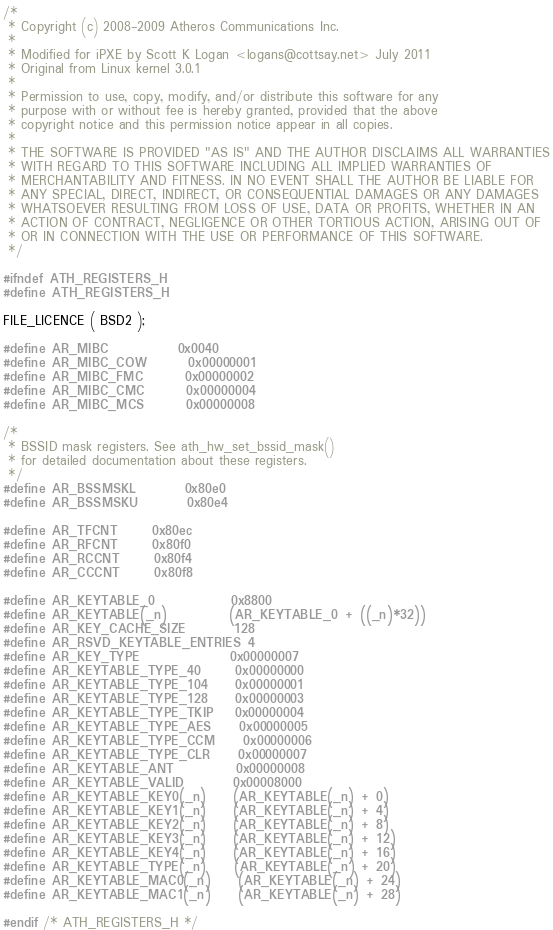Convert code to text. <code><loc_0><loc_0><loc_500><loc_500><_C_>/*
 * Copyright (c) 2008-2009 Atheros Communications Inc.
 *
 * Modified for iPXE by Scott K Logan <logans@cottsay.net> July 2011
 * Original from Linux kernel 3.0.1
 *
 * Permission to use, copy, modify, and/or distribute this software for any
 * purpose with or without fee is hereby granted, provided that the above
 * copyright notice and this permission notice appear in all copies.
 *
 * THE SOFTWARE IS PROVIDED "AS IS" AND THE AUTHOR DISCLAIMS ALL WARRANTIES
 * WITH REGARD TO THIS SOFTWARE INCLUDING ALL IMPLIED WARRANTIES OF
 * MERCHANTABILITY AND FITNESS. IN NO EVENT SHALL THE AUTHOR BE LIABLE FOR
 * ANY SPECIAL, DIRECT, INDIRECT, OR CONSEQUENTIAL DAMAGES OR ANY DAMAGES
 * WHATSOEVER RESULTING FROM LOSS OF USE, DATA OR PROFITS, WHETHER IN AN
 * ACTION OF CONTRACT, NEGLIGENCE OR OTHER TORTIOUS ACTION, ARISING OUT OF
 * OR IN CONNECTION WITH THE USE OR PERFORMANCE OF THIS SOFTWARE.
 */

#ifndef ATH_REGISTERS_H
#define ATH_REGISTERS_H

FILE_LICENCE ( BSD2 );

#define AR_MIBC			0x0040
#define AR_MIBC_COW		0x00000001
#define AR_MIBC_FMC		0x00000002
#define AR_MIBC_CMC		0x00000004
#define AR_MIBC_MCS		0x00000008

/*
 * BSSID mask registers. See ath_hw_set_bssid_mask()
 * for detailed documentation about these registers.
 */
#define AR_BSSMSKL		0x80e0
#define AR_BSSMSKU		0x80e4

#define AR_TFCNT		0x80ec
#define AR_RFCNT		0x80f0
#define AR_RCCNT		0x80f4
#define AR_CCCNT		0x80f8

#define AR_KEYTABLE_0           0x8800
#define AR_KEYTABLE(_n)         (AR_KEYTABLE_0 + ((_n)*32))
#define AR_KEY_CACHE_SIZE       128
#define AR_RSVD_KEYTABLE_ENTRIES 4
#define AR_KEY_TYPE             0x00000007
#define AR_KEYTABLE_TYPE_40     0x00000000
#define AR_KEYTABLE_TYPE_104    0x00000001
#define AR_KEYTABLE_TYPE_128    0x00000003
#define AR_KEYTABLE_TYPE_TKIP   0x00000004
#define AR_KEYTABLE_TYPE_AES    0x00000005
#define AR_KEYTABLE_TYPE_CCM    0x00000006
#define AR_KEYTABLE_TYPE_CLR    0x00000007
#define AR_KEYTABLE_ANT         0x00000008
#define AR_KEYTABLE_VALID       0x00008000
#define AR_KEYTABLE_KEY0(_n)    (AR_KEYTABLE(_n) + 0)
#define AR_KEYTABLE_KEY1(_n)    (AR_KEYTABLE(_n) + 4)
#define AR_KEYTABLE_KEY2(_n)    (AR_KEYTABLE(_n) + 8)
#define AR_KEYTABLE_KEY3(_n)    (AR_KEYTABLE(_n) + 12)
#define AR_KEYTABLE_KEY4(_n)    (AR_KEYTABLE(_n) + 16)
#define AR_KEYTABLE_TYPE(_n)    (AR_KEYTABLE(_n) + 20)
#define AR_KEYTABLE_MAC0(_n)    (AR_KEYTABLE(_n) + 24)
#define AR_KEYTABLE_MAC1(_n)    (AR_KEYTABLE(_n) + 28)

#endif /* ATH_REGISTERS_H */
</code> 